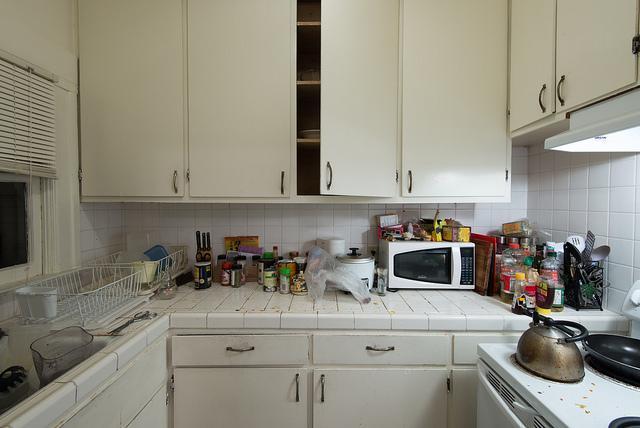How many cars are in the crosswalk?
Give a very brief answer. 0. 